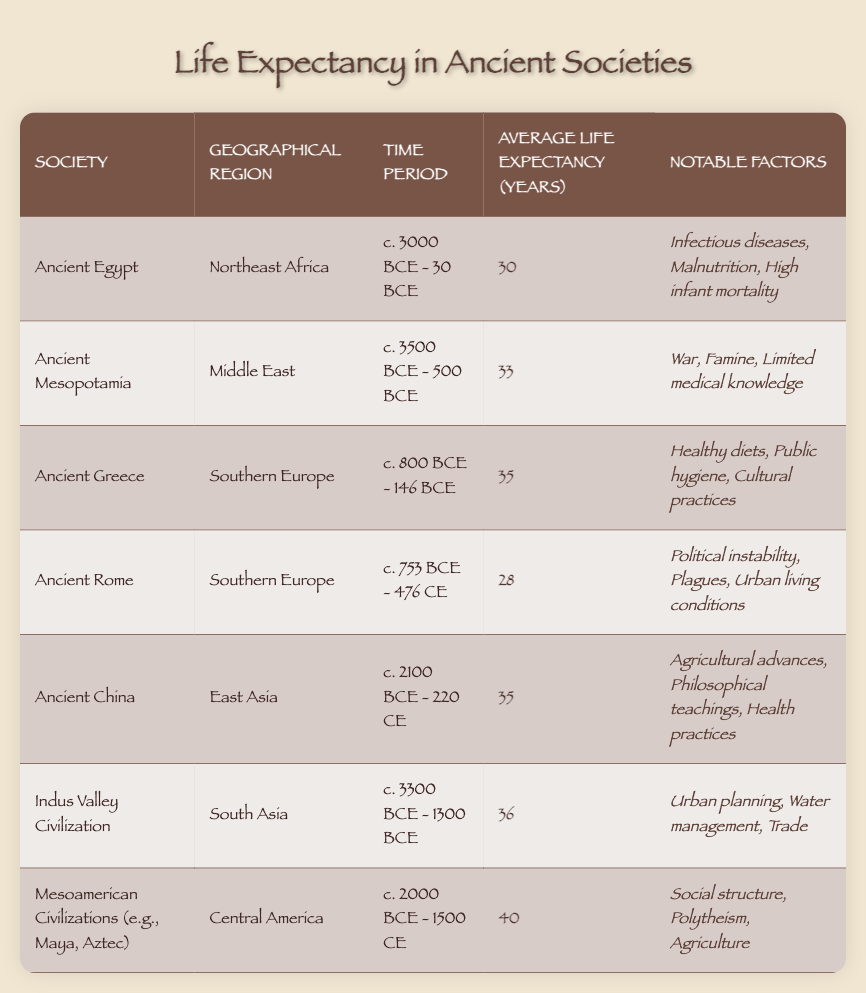What is the average life expectancy of Ancient Egypt? The table specifies that the average life expectancy for Ancient Egypt is given as 30 years.
Answer: 30 Which society had the highest average life expectancy? The table shows that Mesoamerican Civilizations have the highest average life expectancy at 40 years, compared to other societies listed.
Answer: 40 What notable factors contributed to the life expectancy of Ancient Greece? According to the table, the notable factors for Ancient Greece include healthy diets, public hygiene, and cultural practices.
Answer: Healthy diets, public hygiene, cultural practices Is it true that Ancient Rome had a higher life expectancy than Ancient Mesopotamia? Comparing the two societies, Ancient Rome has an average life expectancy of 28 years, while Ancient Mesopotamia has 33 years. Thus, it is false.
Answer: No What is the difference in average life expectancy between the Indus Valley Civilization and Ancient Rome? The Indus Valley Civilization has an average life expectancy of 36 years, while Ancient Rome has 28 years. The difference is 36 - 28 = 8 years.
Answer: 8 List the notable factors for Mesoamerican Civilizations. The table indicates that notable factors for Mesoamerican Civilizations include social structure, polytheism, and agriculture.
Answer: Social structure, polytheism, agriculture How many societies listed have an average life expectancy of 35 years? From the table, both Ancient Greece and Ancient China have an average life expectancy of 35 years. Thus, there are 2 societies with that average.
Answer: 2 If you average the life expectancy of Ancient Egypt, Ancient Mesopotamia, and Ancient Rome, what would that be? The average would be calculated as (30 + 33 + 28) / 3 = 30.33 years.
Answer: 30.33 Which geographical region has the society with the lowest life expectancy? The table shows that Ancient Rome, located in Southern Europe, has the lowest life expectancy at 28 years compared to other societies.
Answer: Southern Europe 